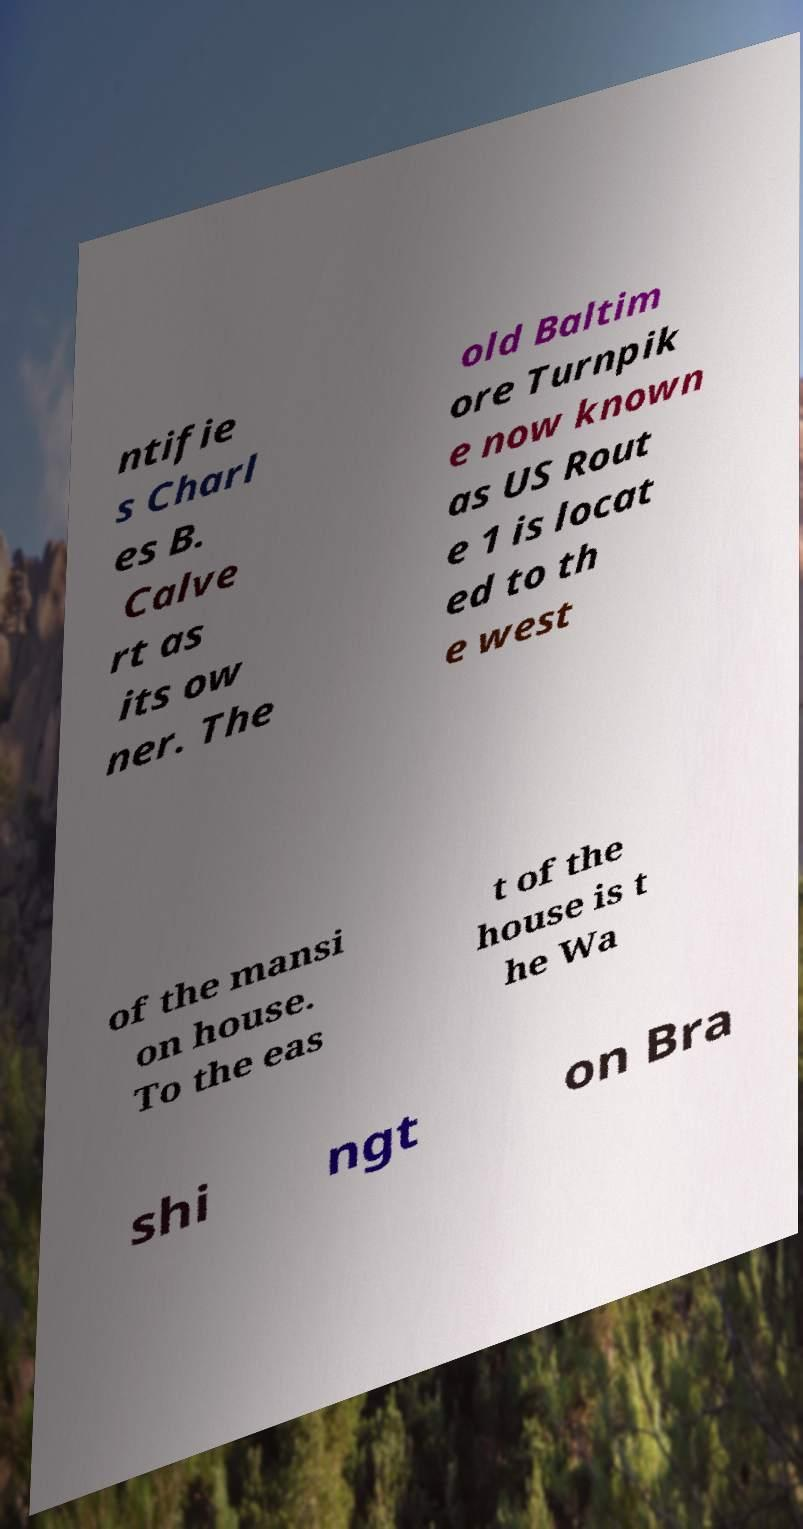Can you accurately transcribe the text from the provided image for me? ntifie s Charl es B. Calve rt as its ow ner. The old Baltim ore Turnpik e now known as US Rout e 1 is locat ed to th e west of the mansi on house. To the eas t of the house is t he Wa shi ngt on Bra 